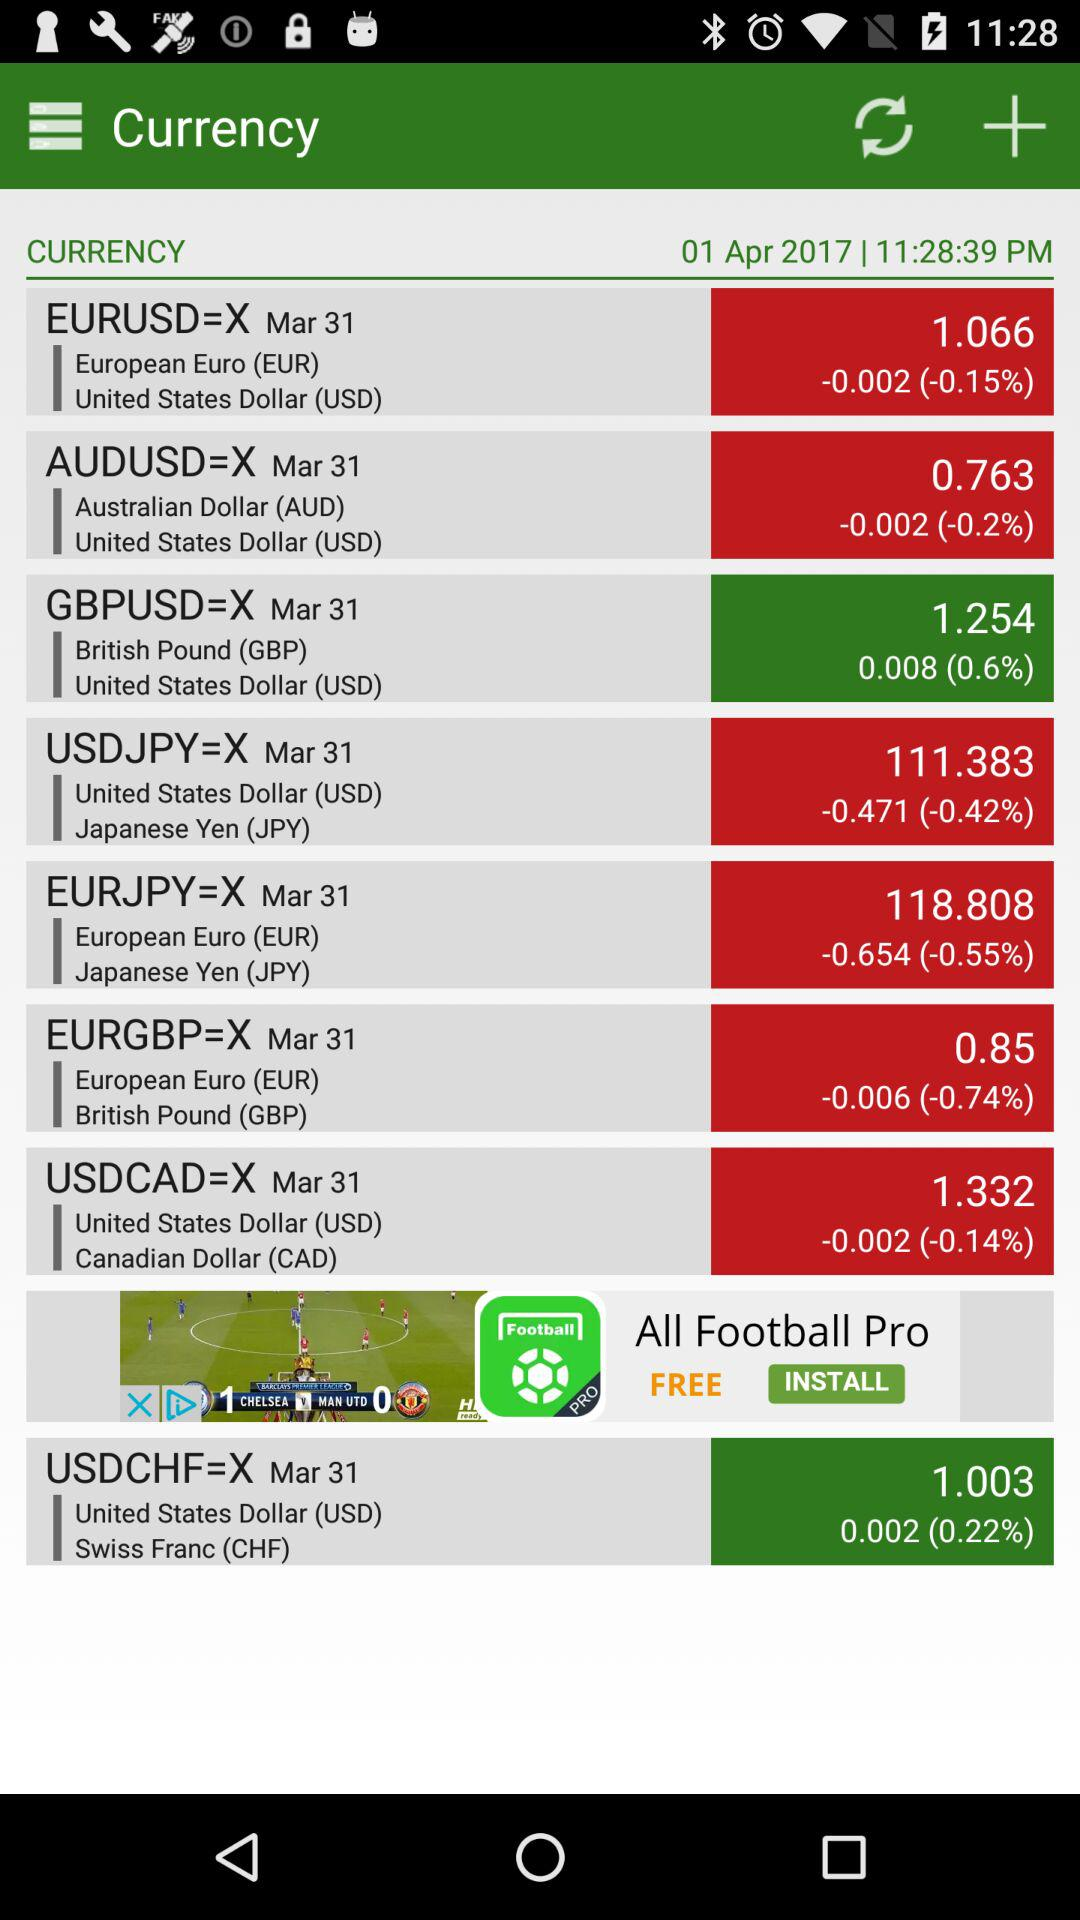What is the time? The time is 11:28:39 PM. 